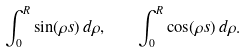<formula> <loc_0><loc_0><loc_500><loc_500>\int _ { 0 } ^ { R } \sin ( \rho s ) \, d \rho , \quad \int _ { 0 } ^ { R } \cos ( \rho s ) \, d \rho .</formula> 